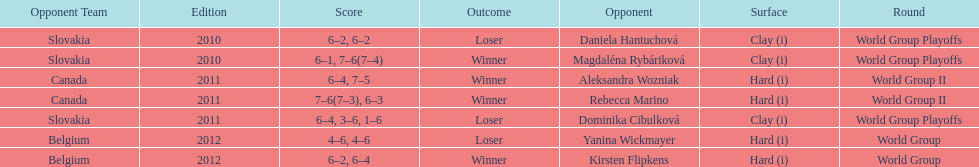Number of games in the match against dominika cibulkova? 3. 